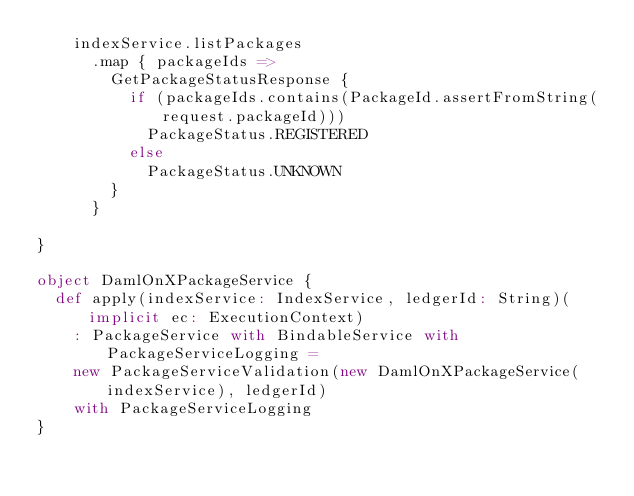Convert code to text. <code><loc_0><loc_0><loc_500><loc_500><_Scala_>    indexService.listPackages
      .map { packageIds =>
        GetPackageStatusResponse {
          if (packageIds.contains(PackageId.assertFromString(request.packageId)))
            PackageStatus.REGISTERED
          else
            PackageStatus.UNKNOWN
        }
      }

}

object DamlOnXPackageService {
  def apply(indexService: IndexService, ledgerId: String)(implicit ec: ExecutionContext)
    : PackageService with BindableService with PackageServiceLogging =
    new PackageServiceValidation(new DamlOnXPackageService(indexService), ledgerId)
    with PackageServiceLogging
}
</code> 